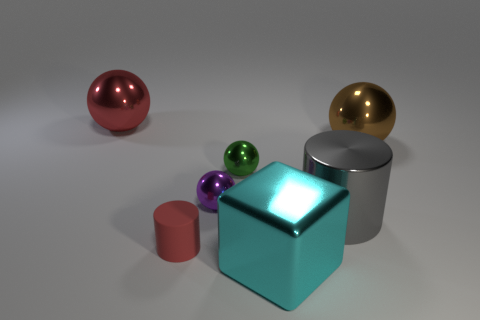Subtract 1 spheres. How many spheres are left? 3 Subtract all purple spheres. How many spheres are left? 3 Subtract all large brown balls. How many balls are left? 3 Subtract all cyan balls. Subtract all red cubes. How many balls are left? 4 Add 2 small shiny things. How many objects exist? 9 Subtract all cylinders. How many objects are left? 5 Subtract all small yellow rubber objects. Subtract all red balls. How many objects are left? 6 Add 2 big cyan shiny things. How many big cyan shiny things are left? 3 Add 7 tiny green things. How many tiny green things exist? 8 Subtract 0 blue blocks. How many objects are left? 7 